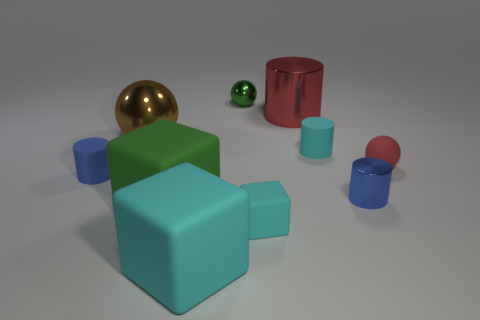Can you tell me what the green object on the left is? The green object on the left of the image appears to be a small, shiny sphere that contrasts with the larger shapes around it. 